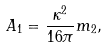<formula> <loc_0><loc_0><loc_500><loc_500>A _ { 1 } = \frac { \kappa ^ { 2 } } { 1 6 \pi } m _ { 2 } ,</formula> 